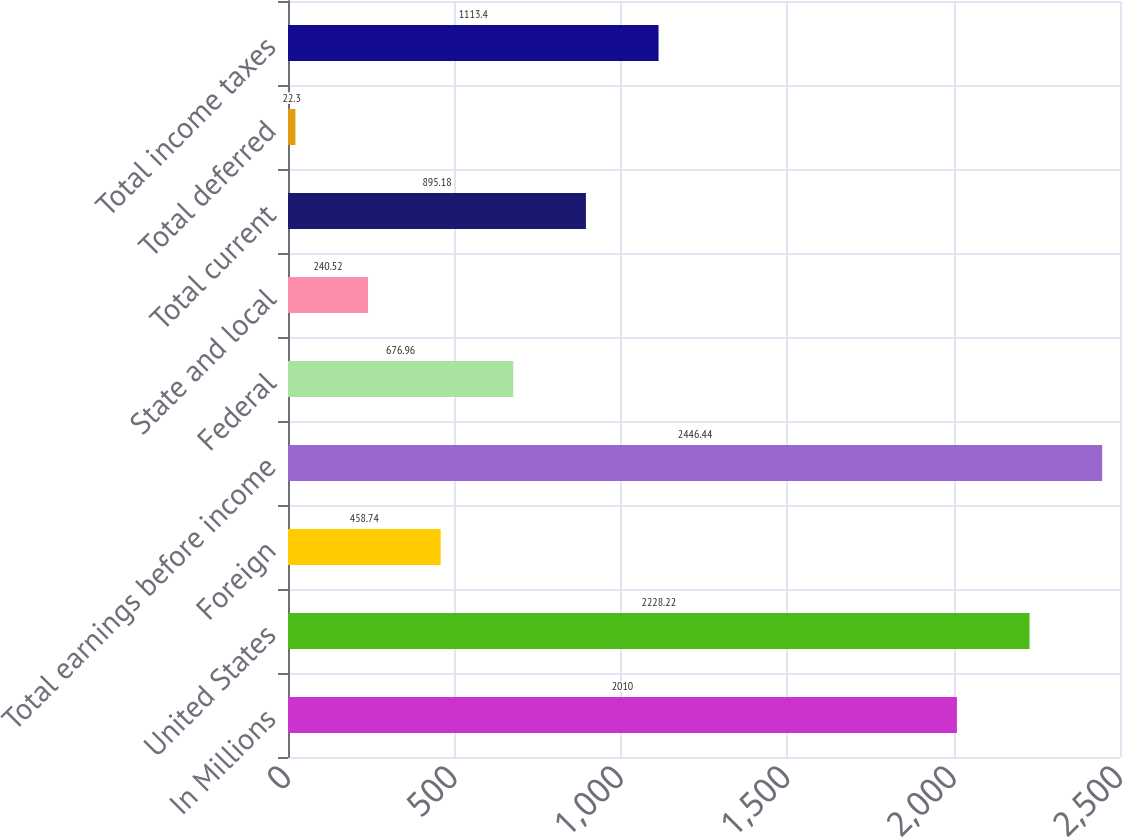<chart> <loc_0><loc_0><loc_500><loc_500><bar_chart><fcel>In Millions<fcel>United States<fcel>Foreign<fcel>Total earnings before income<fcel>Federal<fcel>State and local<fcel>Total current<fcel>Total deferred<fcel>Total income taxes<nl><fcel>2010<fcel>2228.22<fcel>458.74<fcel>2446.44<fcel>676.96<fcel>240.52<fcel>895.18<fcel>22.3<fcel>1113.4<nl></chart> 